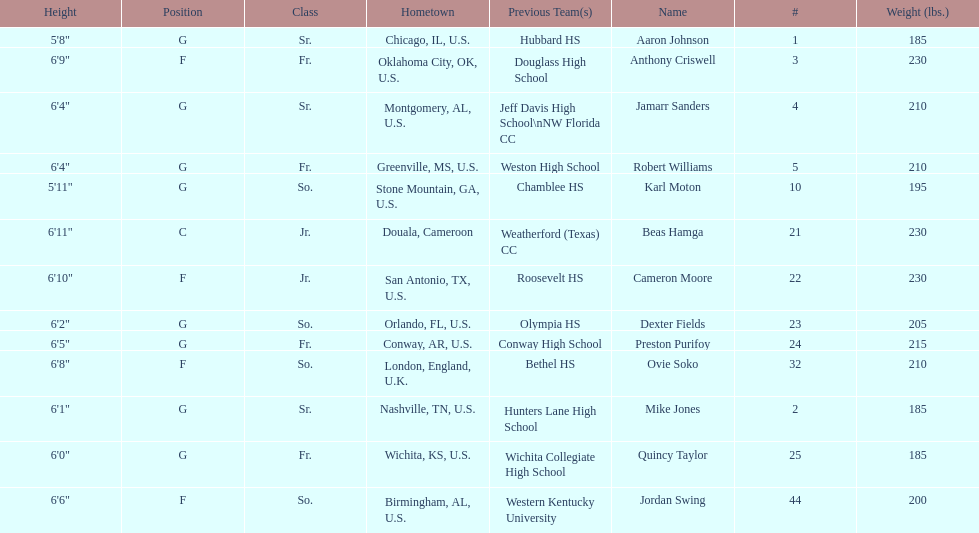Who is first on the roster? Aaron Johnson. 